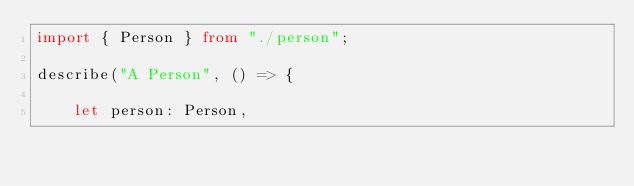Convert code to text. <code><loc_0><loc_0><loc_500><loc_500><_TypeScript_>import { Person } from "./person";

describe("A Person", () => {

    let person: Person,</code> 